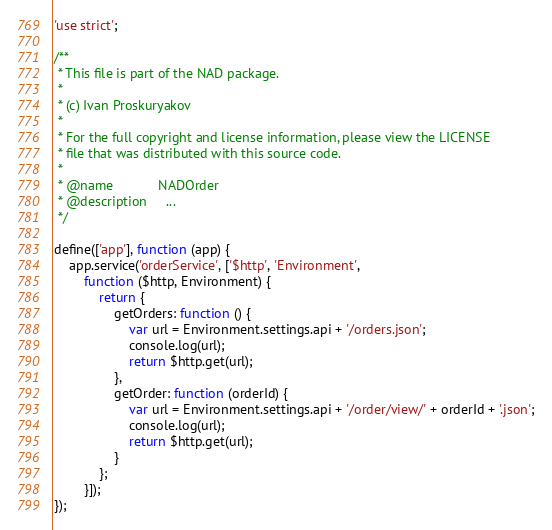Convert code to text. <code><loc_0><loc_0><loc_500><loc_500><_JavaScript_>'use strict';

/**
 * This file is part of the NAD package.
 *
 * (c) Ivan Proskuryakov
 *
 * For the full copyright and license information, please view the LICENSE
 * file that was distributed with this source code.
 *
 * @name            NADOrder
 * @description     ...
 */

define(['app'], function (app) {
    app.service('orderService', ['$http', 'Environment',
        function ($http, Environment) {
            return {
                getOrders: function () {
                    var url = Environment.settings.api + '/orders.json';
                    console.log(url);
                    return $http.get(url);
                },
                getOrder: function (orderId) {
                    var url = Environment.settings.api + '/order/view/' + orderId + '.json';
                    console.log(url);
                    return $http.get(url);
                }
            };
        }]);
});</code> 